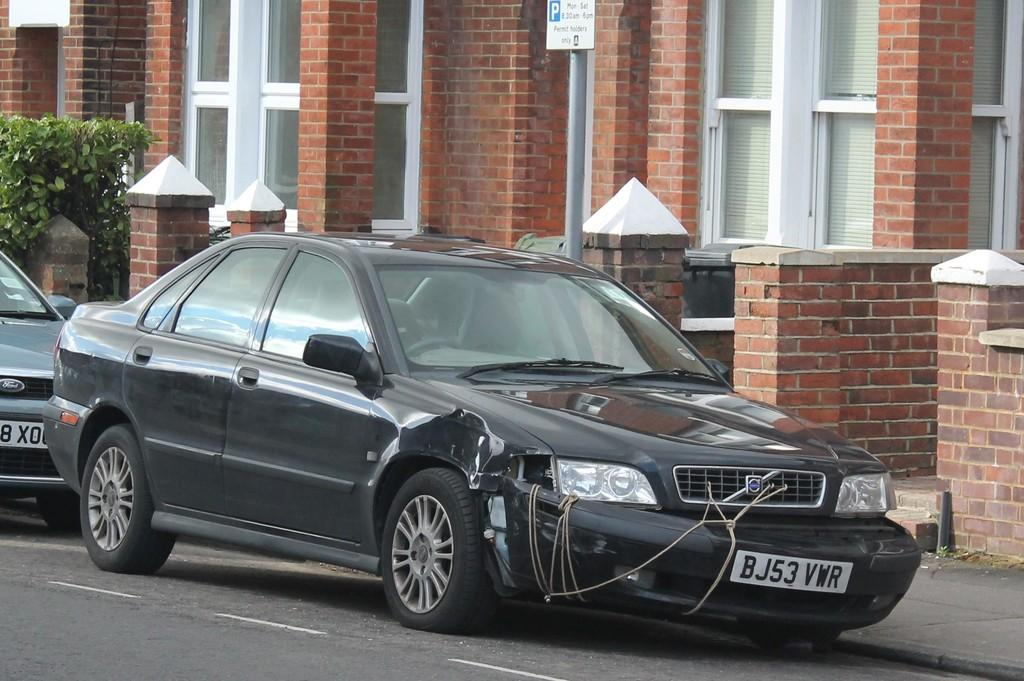<image>
Write a terse but informative summary of the picture. A car that is falling apart is in front of a brick building and has the license plate number BJ53VWR. 